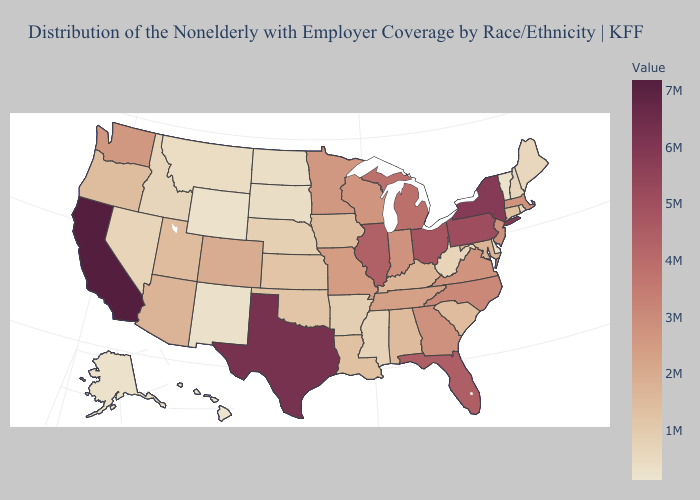Among the states that border North Carolina , which have the highest value?
Give a very brief answer. Georgia. Does Maryland have a higher value than Wyoming?
Keep it brief. Yes. Does Hawaii have the lowest value in the West?
Be succinct. Yes. Does Vermont have the highest value in the Northeast?
Give a very brief answer. No. Does California have the highest value in the USA?
Write a very short answer. Yes. 